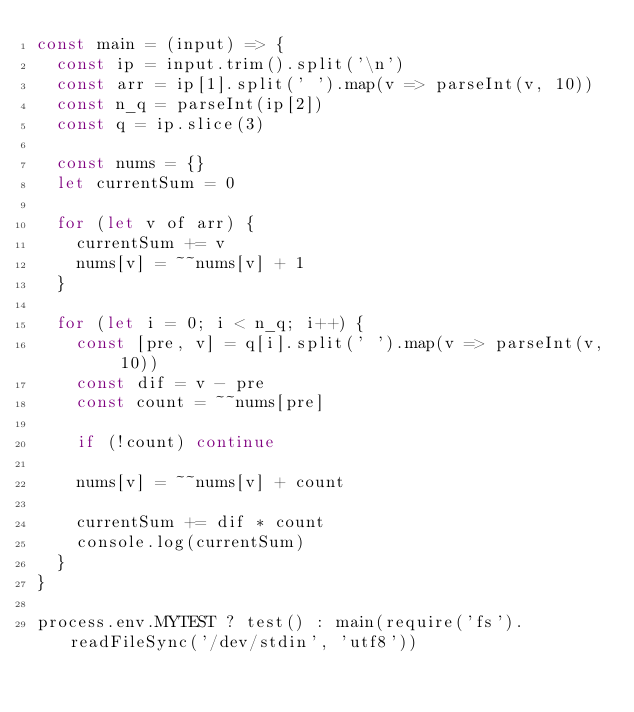<code> <loc_0><loc_0><loc_500><loc_500><_JavaScript_>const main = (input) => {
  const ip = input.trim().split('\n')
  const arr = ip[1].split(' ').map(v => parseInt(v, 10))
  const n_q = parseInt(ip[2])
  const q = ip.slice(3)

  const nums = {}
  let currentSum = 0

  for (let v of arr) {
    currentSum += v
    nums[v] = ~~nums[v] + 1
  }

  for (let i = 0; i < n_q; i++) {
    const [pre, v] = q[i].split(' ').map(v => parseInt(v, 10))
    const dif = v - pre
    const count = ~~nums[pre]

    if (!count) continue

    nums[v] = ~~nums[v] + count

    currentSum += dif * count
    console.log(currentSum)
  }
}

process.env.MYTEST ? test() : main(require('fs').readFileSync('/dev/stdin', 'utf8'))</code> 